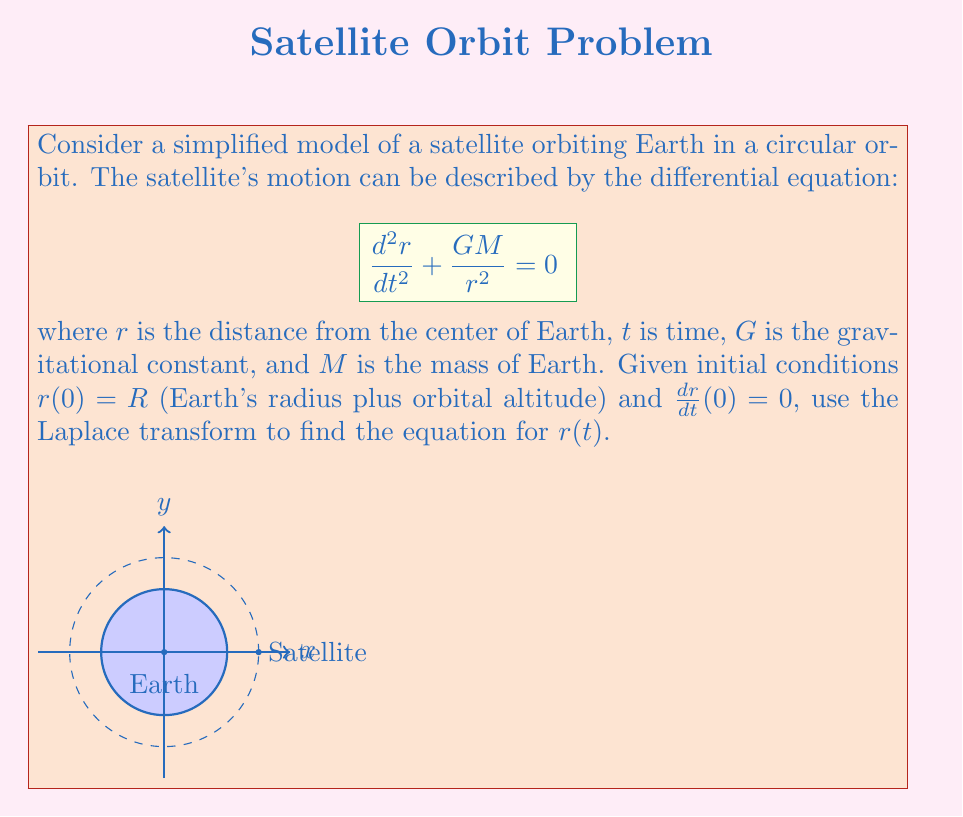Show me your answer to this math problem. Let's solve this problem step by step using the Laplace transform:

1) First, let's take the Laplace transform of both sides of the equation:

   $$\mathcal{L}\left\{\frac{d^2r}{dt^2}\right\} + \mathcal{L}\left\{\frac{GM}{r^2}\right\} = 0$$

2) The Laplace transform of the second derivative is:

   $$s^2R(s) - sr(0) - r'(0) + \mathcal{L}\left\{\frac{GM}{r^2}\right\} = 0$$

   where $R(s)$ is the Laplace transform of $r(t)$.

3) Substituting the initial conditions $r(0) = R$ and $r'(0) = 0$:

   $$s^2R(s) - sR + \mathcal{L}\left\{\frac{GM}{r^2}\right\} = 0$$

4) The term $\frac{GM}{r^2}$ is nonlinear, making it difficult to solve directly. However, for a circular orbit, $r$ is constant. Let's call this constant $R$. Then:

   $$s^2R(s) - sR + \frac{GM}{R^2} = 0$$

5) Solving for $R(s)$:

   $$R(s) = \frac{sR}{s^2} - \frac{GM}{R^2s^2} = R\left(\frac{1}{s} - \frac{GM}{R^3s^2}\right)$$

6) To find $r(t)$, we need to take the inverse Laplace transform:

   $$r(t) = \mathcal{L}^{-1}\left\{R\left(\frac{1}{s} - \frac{GM}{R^3s^2}\right)\right\}$$

7) Using the inverse Laplace transform properties:

   $$r(t) = R - \frac{GM}{R^3}t$$

8) For a circular orbit, $r(t)$ should be constant. This means the coefficient of $t$ must be zero:

   $$\frac{GM}{R^3} = 0$$

   This is only true if $R$ approaches infinity, which is not physical. This shows that our simplified model doesn't fully capture the dynamics of circular orbits.

9) In reality, for a circular orbit, the centripetal acceleration balances the gravitational force:

   $$\frac{v^2}{R} = \frac{GM}{R^2}$$

   where $v$ is the orbital velocity.

10) Solving for $v$:

    $$v = \sqrt{\frac{GM}{R}}$$

11) The period of the orbit is:

    $$T = \frac{2\pi R}{v} = 2\pi R\sqrt{\frac{R}{GM}}$$

Therefore, the correct equation for $r(t)$ in a circular orbit is:

$$r(t) = R$$

This constant solution satisfies the initial conditions and represents a stable circular orbit.
Answer: $r(t) = R$ 